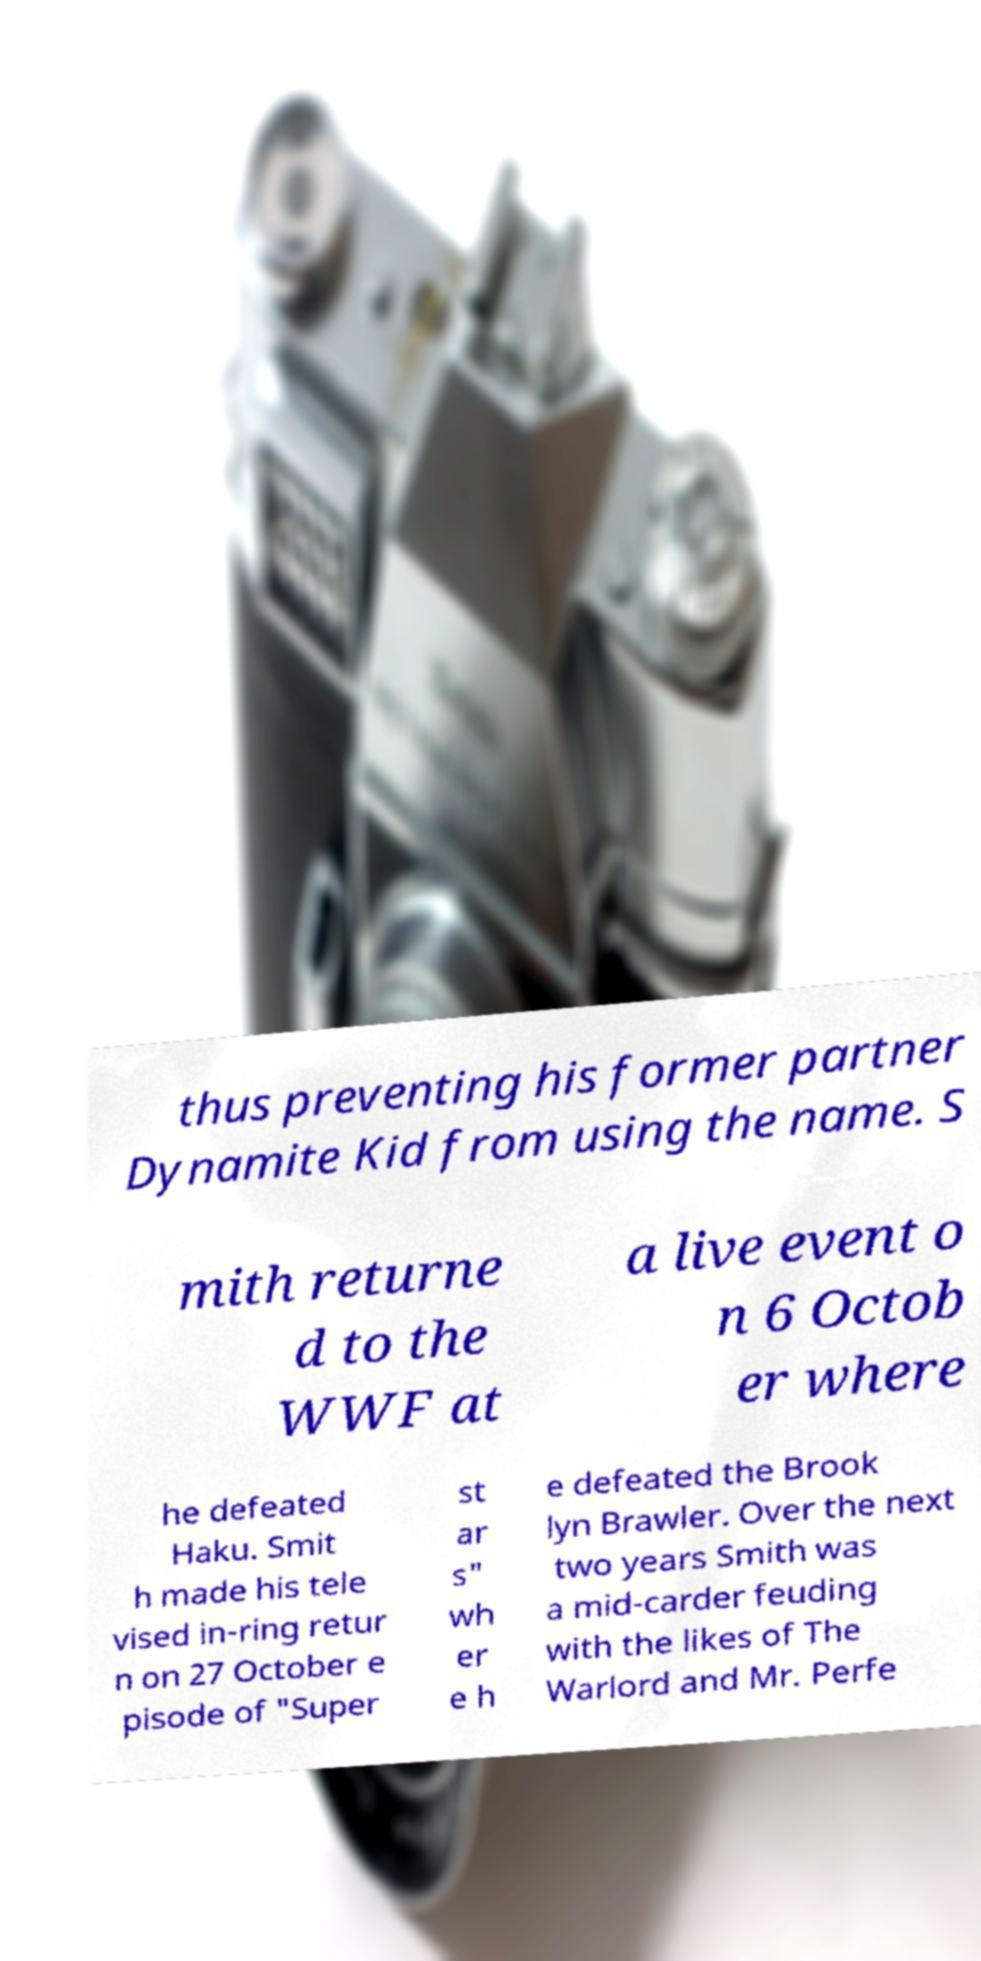What messages or text are displayed in this image? I need them in a readable, typed format. thus preventing his former partner Dynamite Kid from using the name. S mith returne d to the WWF at a live event o n 6 Octob er where he defeated Haku. Smit h made his tele vised in-ring retur n on 27 October e pisode of "Super st ar s" wh er e h e defeated the Brook lyn Brawler. Over the next two years Smith was a mid-carder feuding with the likes of The Warlord and Mr. Perfe 